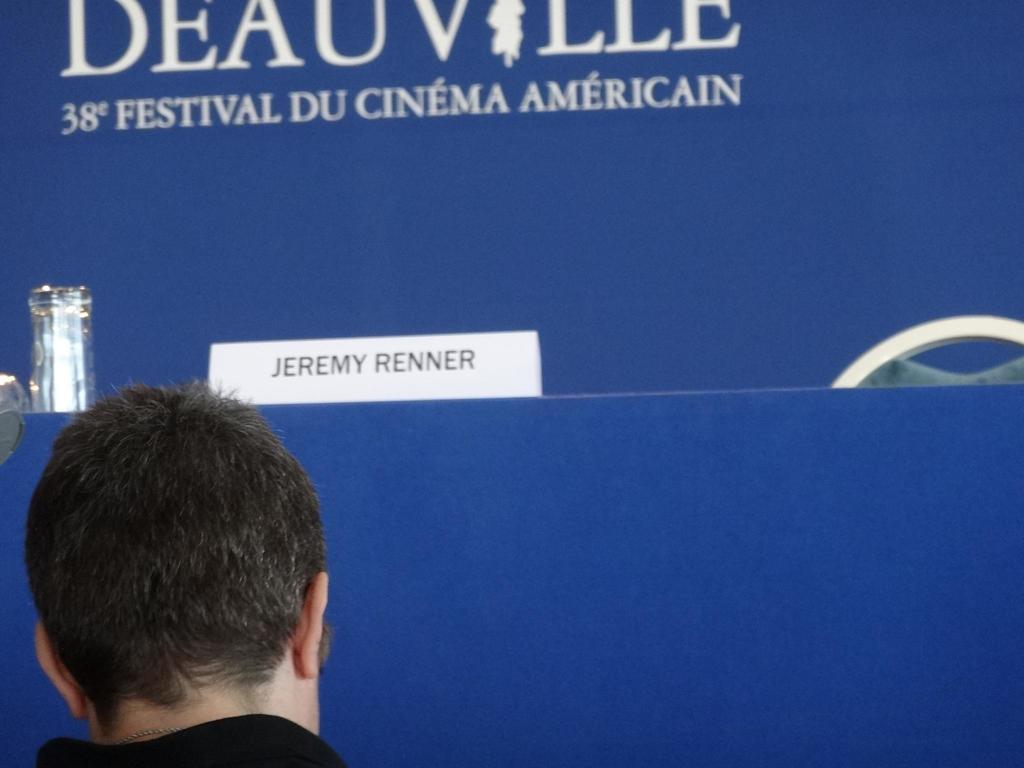Who or what is at the bottom of the image? There is a person at the bottom of the image. What can be seen in the background of the image? There is a board, a name board, a chair, a glass, and some unspecified objects in the background of the image. What is written on the board in the background? There is text visible on the board in the background. What type of fang can be seen in the image? There is no fang present in the image. Where is the lunchroom located in the image? There is no mention of a lunchroom in the image. 